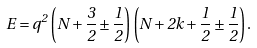<formula> <loc_0><loc_0><loc_500><loc_500>E = q ^ { 2 } \left ( N + \frac { 3 } { 2 } \pm \frac { 1 } { 2 } \right ) \left ( N + 2 k + \frac { 1 } { 2 } \pm \frac { 1 } { 2 } \right ) .</formula> 